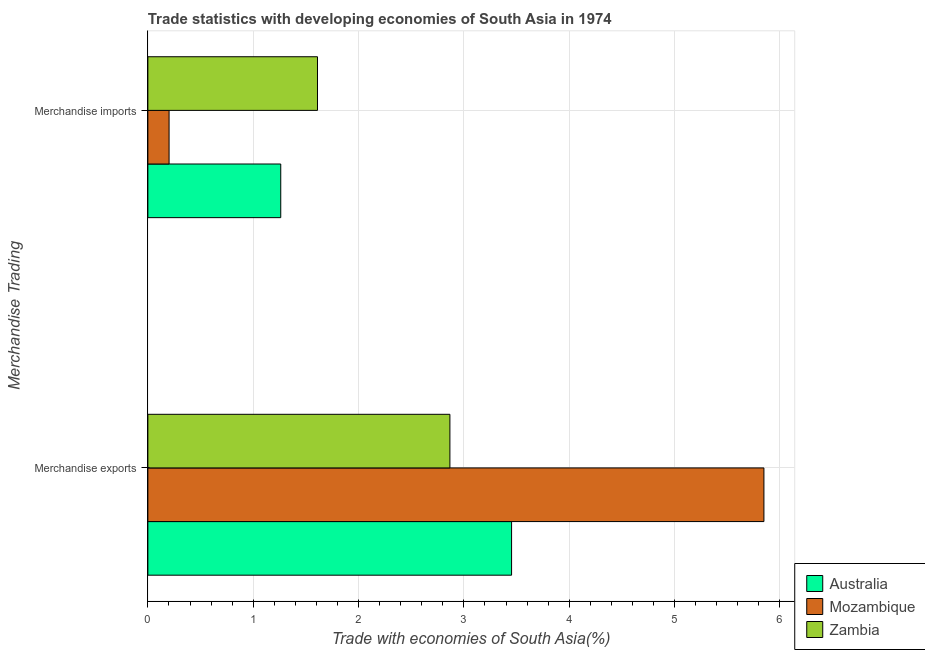How many different coloured bars are there?
Offer a terse response. 3. Are the number of bars on each tick of the Y-axis equal?
Your response must be concise. Yes. How many bars are there on the 1st tick from the top?
Offer a terse response. 3. What is the label of the 2nd group of bars from the top?
Offer a very short reply. Merchandise exports. What is the merchandise imports in Zambia?
Your answer should be very brief. 1.61. Across all countries, what is the maximum merchandise imports?
Your response must be concise. 1.61. Across all countries, what is the minimum merchandise imports?
Your response must be concise. 0.2. In which country was the merchandise exports maximum?
Offer a very short reply. Mozambique. In which country was the merchandise imports minimum?
Your answer should be very brief. Mozambique. What is the total merchandise imports in the graph?
Ensure brevity in your answer.  3.07. What is the difference between the merchandise imports in Zambia and that in Mozambique?
Offer a very short reply. 1.41. What is the difference between the merchandise imports in Zambia and the merchandise exports in Australia?
Keep it short and to the point. -1.84. What is the average merchandise imports per country?
Give a very brief answer. 1.02. What is the difference between the merchandise exports and merchandise imports in Australia?
Offer a terse response. 2.19. What is the ratio of the merchandise imports in Mozambique to that in Australia?
Provide a short and direct response. 0.16. In how many countries, is the merchandise imports greater than the average merchandise imports taken over all countries?
Ensure brevity in your answer.  2. What does the 2nd bar from the top in Merchandise exports represents?
Keep it short and to the point. Mozambique. What does the 3rd bar from the bottom in Merchandise imports represents?
Provide a succinct answer. Zambia. How many bars are there?
Keep it short and to the point. 6. What is the difference between two consecutive major ticks on the X-axis?
Provide a short and direct response. 1. Does the graph contain any zero values?
Ensure brevity in your answer.  No. Does the graph contain grids?
Offer a very short reply. Yes. Where does the legend appear in the graph?
Ensure brevity in your answer.  Bottom right. How are the legend labels stacked?
Your answer should be compact. Vertical. What is the title of the graph?
Offer a terse response. Trade statistics with developing economies of South Asia in 1974. Does "Aruba" appear as one of the legend labels in the graph?
Offer a terse response. No. What is the label or title of the X-axis?
Give a very brief answer. Trade with economies of South Asia(%). What is the label or title of the Y-axis?
Keep it short and to the point. Merchandise Trading. What is the Trade with economies of South Asia(%) in Australia in Merchandise exports?
Give a very brief answer. 3.45. What is the Trade with economies of South Asia(%) of Mozambique in Merchandise exports?
Provide a succinct answer. 5.85. What is the Trade with economies of South Asia(%) of Zambia in Merchandise exports?
Provide a short and direct response. 2.87. What is the Trade with economies of South Asia(%) of Australia in Merchandise imports?
Offer a terse response. 1.26. What is the Trade with economies of South Asia(%) in Mozambique in Merchandise imports?
Make the answer very short. 0.2. What is the Trade with economies of South Asia(%) in Zambia in Merchandise imports?
Your answer should be compact. 1.61. Across all Merchandise Trading, what is the maximum Trade with economies of South Asia(%) in Australia?
Give a very brief answer. 3.45. Across all Merchandise Trading, what is the maximum Trade with economies of South Asia(%) in Mozambique?
Your answer should be very brief. 5.85. Across all Merchandise Trading, what is the maximum Trade with economies of South Asia(%) of Zambia?
Ensure brevity in your answer.  2.87. Across all Merchandise Trading, what is the minimum Trade with economies of South Asia(%) of Australia?
Ensure brevity in your answer.  1.26. Across all Merchandise Trading, what is the minimum Trade with economies of South Asia(%) of Mozambique?
Your answer should be very brief. 0.2. Across all Merchandise Trading, what is the minimum Trade with economies of South Asia(%) in Zambia?
Ensure brevity in your answer.  1.61. What is the total Trade with economies of South Asia(%) of Australia in the graph?
Offer a very short reply. 4.71. What is the total Trade with economies of South Asia(%) in Mozambique in the graph?
Keep it short and to the point. 6.05. What is the total Trade with economies of South Asia(%) in Zambia in the graph?
Offer a terse response. 4.48. What is the difference between the Trade with economies of South Asia(%) of Australia in Merchandise exports and that in Merchandise imports?
Provide a succinct answer. 2.19. What is the difference between the Trade with economies of South Asia(%) of Mozambique in Merchandise exports and that in Merchandise imports?
Provide a short and direct response. 5.65. What is the difference between the Trade with economies of South Asia(%) of Zambia in Merchandise exports and that in Merchandise imports?
Give a very brief answer. 1.26. What is the difference between the Trade with economies of South Asia(%) in Australia in Merchandise exports and the Trade with economies of South Asia(%) in Mozambique in Merchandise imports?
Offer a terse response. 3.25. What is the difference between the Trade with economies of South Asia(%) of Australia in Merchandise exports and the Trade with economies of South Asia(%) of Zambia in Merchandise imports?
Make the answer very short. 1.84. What is the difference between the Trade with economies of South Asia(%) of Mozambique in Merchandise exports and the Trade with economies of South Asia(%) of Zambia in Merchandise imports?
Keep it short and to the point. 4.24. What is the average Trade with economies of South Asia(%) of Australia per Merchandise Trading?
Your answer should be compact. 2.36. What is the average Trade with economies of South Asia(%) in Mozambique per Merchandise Trading?
Keep it short and to the point. 3.02. What is the average Trade with economies of South Asia(%) in Zambia per Merchandise Trading?
Ensure brevity in your answer.  2.24. What is the difference between the Trade with economies of South Asia(%) in Australia and Trade with economies of South Asia(%) in Mozambique in Merchandise exports?
Your response must be concise. -2.4. What is the difference between the Trade with economies of South Asia(%) in Australia and Trade with economies of South Asia(%) in Zambia in Merchandise exports?
Your answer should be very brief. 0.59. What is the difference between the Trade with economies of South Asia(%) of Mozambique and Trade with economies of South Asia(%) of Zambia in Merchandise exports?
Offer a terse response. 2.98. What is the difference between the Trade with economies of South Asia(%) in Australia and Trade with economies of South Asia(%) in Mozambique in Merchandise imports?
Offer a terse response. 1.06. What is the difference between the Trade with economies of South Asia(%) of Australia and Trade with economies of South Asia(%) of Zambia in Merchandise imports?
Give a very brief answer. -0.35. What is the difference between the Trade with economies of South Asia(%) in Mozambique and Trade with economies of South Asia(%) in Zambia in Merchandise imports?
Make the answer very short. -1.41. What is the ratio of the Trade with economies of South Asia(%) of Australia in Merchandise exports to that in Merchandise imports?
Ensure brevity in your answer.  2.74. What is the ratio of the Trade with economies of South Asia(%) of Mozambique in Merchandise exports to that in Merchandise imports?
Make the answer very short. 29.05. What is the ratio of the Trade with economies of South Asia(%) in Zambia in Merchandise exports to that in Merchandise imports?
Your response must be concise. 1.78. What is the difference between the highest and the second highest Trade with economies of South Asia(%) of Australia?
Offer a terse response. 2.19. What is the difference between the highest and the second highest Trade with economies of South Asia(%) in Mozambique?
Ensure brevity in your answer.  5.65. What is the difference between the highest and the second highest Trade with economies of South Asia(%) of Zambia?
Make the answer very short. 1.26. What is the difference between the highest and the lowest Trade with economies of South Asia(%) of Australia?
Give a very brief answer. 2.19. What is the difference between the highest and the lowest Trade with economies of South Asia(%) in Mozambique?
Offer a very short reply. 5.65. What is the difference between the highest and the lowest Trade with economies of South Asia(%) in Zambia?
Your response must be concise. 1.26. 